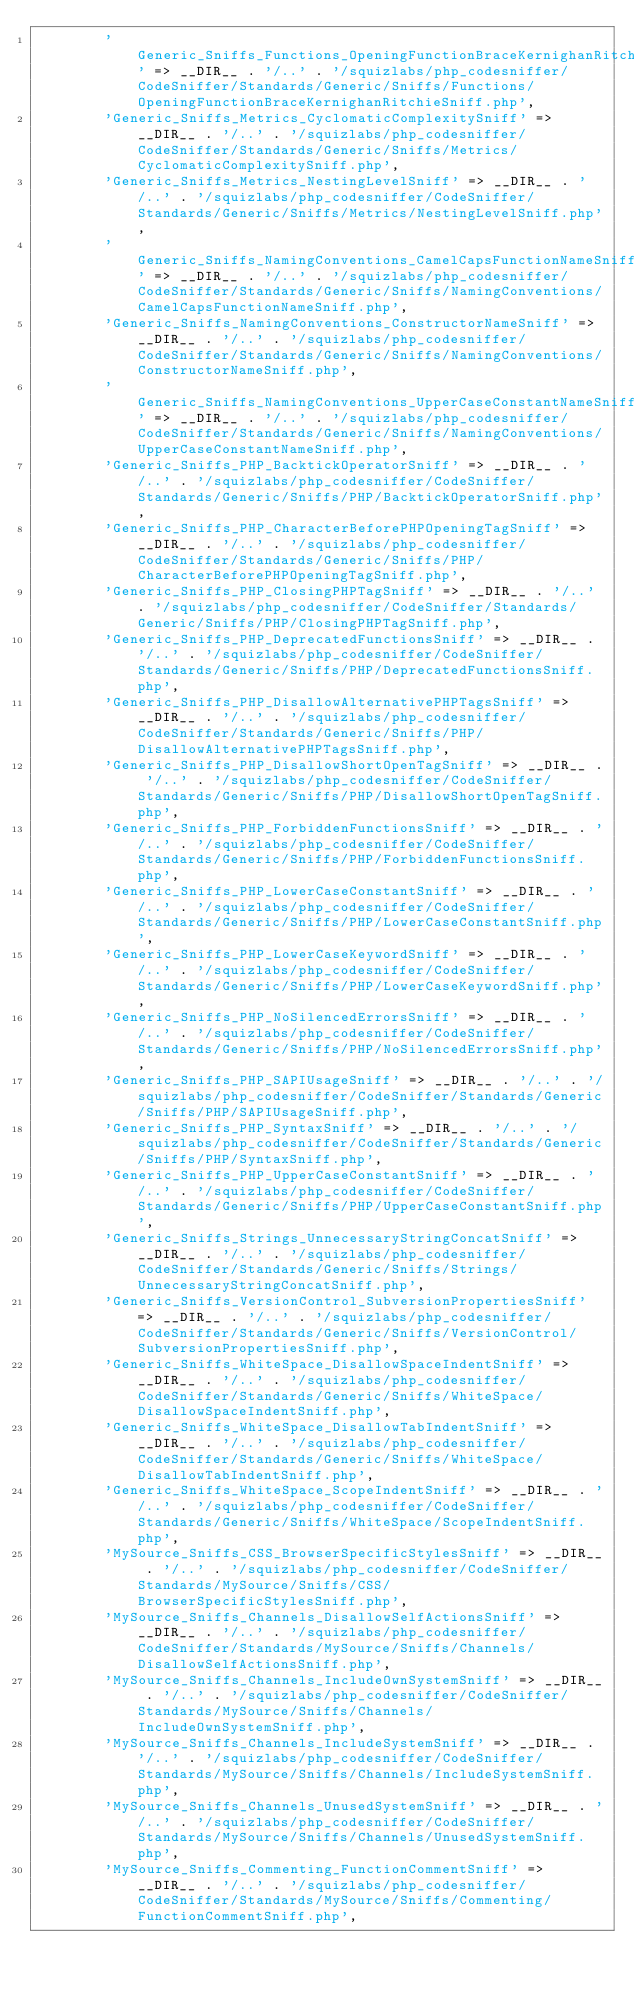<code> <loc_0><loc_0><loc_500><loc_500><_PHP_>        'Generic_Sniffs_Functions_OpeningFunctionBraceKernighanRitchieSniff' => __DIR__ . '/..' . '/squizlabs/php_codesniffer/CodeSniffer/Standards/Generic/Sniffs/Functions/OpeningFunctionBraceKernighanRitchieSniff.php',
        'Generic_Sniffs_Metrics_CyclomaticComplexitySniff' => __DIR__ . '/..' . '/squizlabs/php_codesniffer/CodeSniffer/Standards/Generic/Sniffs/Metrics/CyclomaticComplexitySniff.php',
        'Generic_Sniffs_Metrics_NestingLevelSniff' => __DIR__ . '/..' . '/squizlabs/php_codesniffer/CodeSniffer/Standards/Generic/Sniffs/Metrics/NestingLevelSniff.php',
        'Generic_Sniffs_NamingConventions_CamelCapsFunctionNameSniff' => __DIR__ . '/..' . '/squizlabs/php_codesniffer/CodeSniffer/Standards/Generic/Sniffs/NamingConventions/CamelCapsFunctionNameSniff.php',
        'Generic_Sniffs_NamingConventions_ConstructorNameSniff' => __DIR__ . '/..' . '/squizlabs/php_codesniffer/CodeSniffer/Standards/Generic/Sniffs/NamingConventions/ConstructorNameSniff.php',
        'Generic_Sniffs_NamingConventions_UpperCaseConstantNameSniff' => __DIR__ . '/..' . '/squizlabs/php_codesniffer/CodeSniffer/Standards/Generic/Sniffs/NamingConventions/UpperCaseConstantNameSniff.php',
        'Generic_Sniffs_PHP_BacktickOperatorSniff' => __DIR__ . '/..' . '/squizlabs/php_codesniffer/CodeSniffer/Standards/Generic/Sniffs/PHP/BacktickOperatorSniff.php',
        'Generic_Sniffs_PHP_CharacterBeforePHPOpeningTagSniff' => __DIR__ . '/..' . '/squizlabs/php_codesniffer/CodeSniffer/Standards/Generic/Sniffs/PHP/CharacterBeforePHPOpeningTagSniff.php',
        'Generic_Sniffs_PHP_ClosingPHPTagSniff' => __DIR__ . '/..' . '/squizlabs/php_codesniffer/CodeSniffer/Standards/Generic/Sniffs/PHP/ClosingPHPTagSniff.php',
        'Generic_Sniffs_PHP_DeprecatedFunctionsSniff' => __DIR__ . '/..' . '/squizlabs/php_codesniffer/CodeSniffer/Standards/Generic/Sniffs/PHP/DeprecatedFunctionsSniff.php',
        'Generic_Sniffs_PHP_DisallowAlternativePHPTagsSniff' => __DIR__ . '/..' . '/squizlabs/php_codesniffer/CodeSniffer/Standards/Generic/Sniffs/PHP/DisallowAlternativePHPTagsSniff.php',
        'Generic_Sniffs_PHP_DisallowShortOpenTagSniff' => __DIR__ . '/..' . '/squizlabs/php_codesniffer/CodeSniffer/Standards/Generic/Sniffs/PHP/DisallowShortOpenTagSniff.php',
        'Generic_Sniffs_PHP_ForbiddenFunctionsSniff' => __DIR__ . '/..' . '/squizlabs/php_codesniffer/CodeSniffer/Standards/Generic/Sniffs/PHP/ForbiddenFunctionsSniff.php',
        'Generic_Sniffs_PHP_LowerCaseConstantSniff' => __DIR__ . '/..' . '/squizlabs/php_codesniffer/CodeSniffer/Standards/Generic/Sniffs/PHP/LowerCaseConstantSniff.php',
        'Generic_Sniffs_PHP_LowerCaseKeywordSniff' => __DIR__ . '/..' . '/squizlabs/php_codesniffer/CodeSniffer/Standards/Generic/Sniffs/PHP/LowerCaseKeywordSniff.php',
        'Generic_Sniffs_PHP_NoSilencedErrorsSniff' => __DIR__ . '/..' . '/squizlabs/php_codesniffer/CodeSniffer/Standards/Generic/Sniffs/PHP/NoSilencedErrorsSniff.php',
        'Generic_Sniffs_PHP_SAPIUsageSniff' => __DIR__ . '/..' . '/squizlabs/php_codesniffer/CodeSniffer/Standards/Generic/Sniffs/PHP/SAPIUsageSniff.php',
        'Generic_Sniffs_PHP_SyntaxSniff' => __DIR__ . '/..' . '/squizlabs/php_codesniffer/CodeSniffer/Standards/Generic/Sniffs/PHP/SyntaxSniff.php',
        'Generic_Sniffs_PHP_UpperCaseConstantSniff' => __DIR__ . '/..' . '/squizlabs/php_codesniffer/CodeSniffer/Standards/Generic/Sniffs/PHP/UpperCaseConstantSniff.php',
        'Generic_Sniffs_Strings_UnnecessaryStringConcatSniff' => __DIR__ . '/..' . '/squizlabs/php_codesniffer/CodeSniffer/Standards/Generic/Sniffs/Strings/UnnecessaryStringConcatSniff.php',
        'Generic_Sniffs_VersionControl_SubversionPropertiesSniff' => __DIR__ . '/..' . '/squizlabs/php_codesniffer/CodeSniffer/Standards/Generic/Sniffs/VersionControl/SubversionPropertiesSniff.php',
        'Generic_Sniffs_WhiteSpace_DisallowSpaceIndentSniff' => __DIR__ . '/..' . '/squizlabs/php_codesniffer/CodeSniffer/Standards/Generic/Sniffs/WhiteSpace/DisallowSpaceIndentSniff.php',
        'Generic_Sniffs_WhiteSpace_DisallowTabIndentSniff' => __DIR__ . '/..' . '/squizlabs/php_codesniffer/CodeSniffer/Standards/Generic/Sniffs/WhiteSpace/DisallowTabIndentSniff.php',
        'Generic_Sniffs_WhiteSpace_ScopeIndentSniff' => __DIR__ . '/..' . '/squizlabs/php_codesniffer/CodeSniffer/Standards/Generic/Sniffs/WhiteSpace/ScopeIndentSniff.php',
        'MySource_Sniffs_CSS_BrowserSpecificStylesSniff' => __DIR__ . '/..' . '/squizlabs/php_codesniffer/CodeSniffer/Standards/MySource/Sniffs/CSS/BrowserSpecificStylesSniff.php',
        'MySource_Sniffs_Channels_DisallowSelfActionsSniff' => __DIR__ . '/..' . '/squizlabs/php_codesniffer/CodeSniffer/Standards/MySource/Sniffs/Channels/DisallowSelfActionsSniff.php',
        'MySource_Sniffs_Channels_IncludeOwnSystemSniff' => __DIR__ . '/..' . '/squizlabs/php_codesniffer/CodeSniffer/Standards/MySource/Sniffs/Channels/IncludeOwnSystemSniff.php',
        'MySource_Sniffs_Channels_IncludeSystemSniff' => __DIR__ . '/..' . '/squizlabs/php_codesniffer/CodeSniffer/Standards/MySource/Sniffs/Channels/IncludeSystemSniff.php',
        'MySource_Sniffs_Channels_UnusedSystemSniff' => __DIR__ . '/..' . '/squizlabs/php_codesniffer/CodeSniffer/Standards/MySource/Sniffs/Channels/UnusedSystemSniff.php',
        'MySource_Sniffs_Commenting_FunctionCommentSniff' => __DIR__ . '/..' . '/squizlabs/php_codesniffer/CodeSniffer/Standards/MySource/Sniffs/Commenting/FunctionCommentSniff.php',</code> 